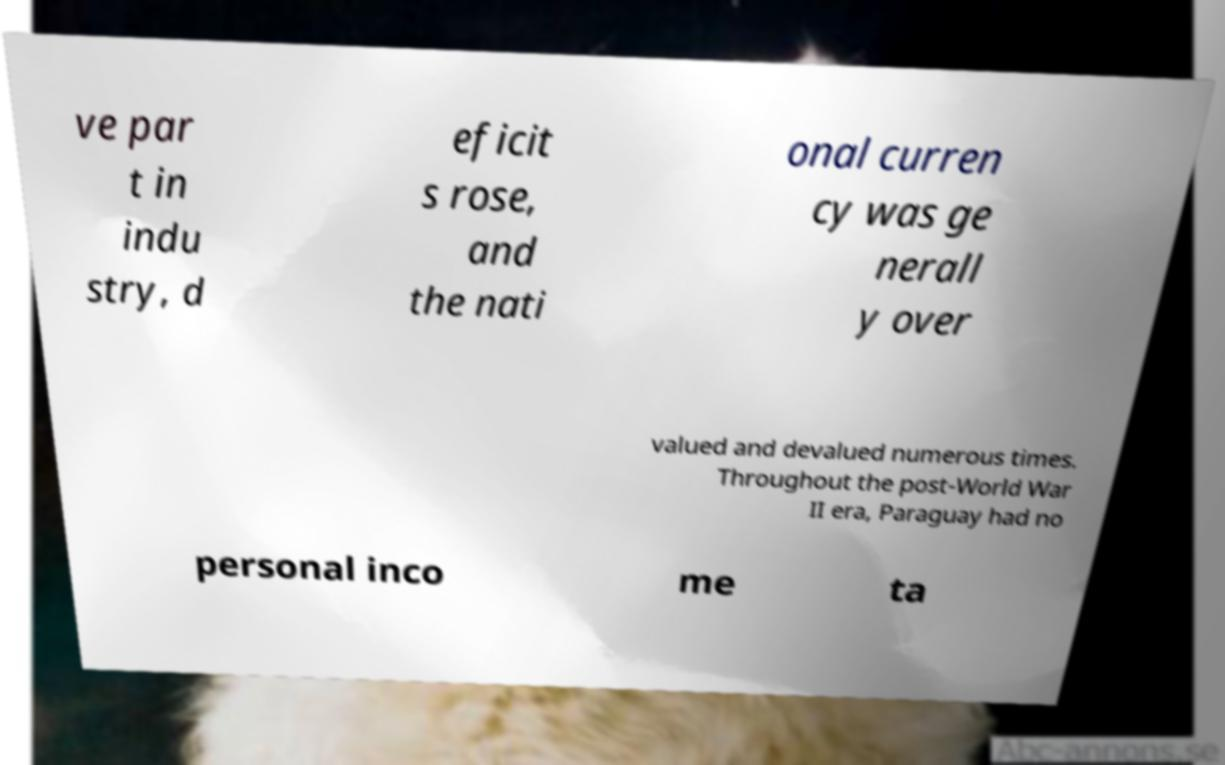What messages or text are displayed in this image? I need them in a readable, typed format. ve par t in indu stry, d eficit s rose, and the nati onal curren cy was ge nerall y over valued and devalued numerous times. Throughout the post-World War II era, Paraguay had no personal inco me ta 